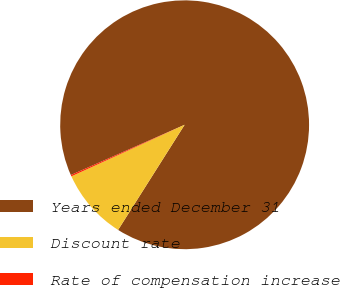Convert chart. <chart><loc_0><loc_0><loc_500><loc_500><pie_chart><fcel>Years ended December 31<fcel>Discount rate<fcel>Rate of compensation increase<nl><fcel>90.6%<fcel>9.22%<fcel>0.18%<nl></chart> 